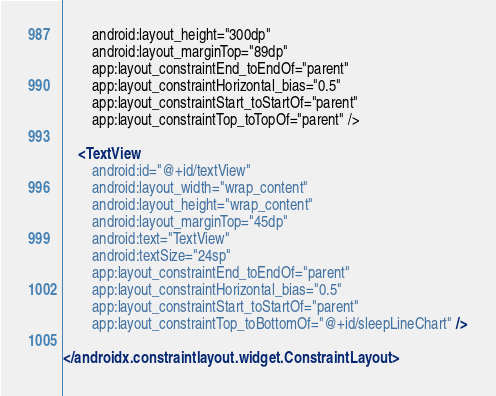Convert code to text. <code><loc_0><loc_0><loc_500><loc_500><_XML_>        android:layout_height="300dp"
        android:layout_marginTop="89dp"
        app:layout_constraintEnd_toEndOf="parent"
        app:layout_constraintHorizontal_bias="0.5"
        app:layout_constraintStart_toStartOf="parent"
        app:layout_constraintTop_toTopOf="parent" />

    <TextView
        android:id="@+id/textView"
        android:layout_width="wrap_content"
        android:layout_height="wrap_content"
        android:layout_marginTop="45dp"
        android:text="TextView"
        android:textSize="24sp"
        app:layout_constraintEnd_toEndOf="parent"
        app:layout_constraintHorizontal_bias="0.5"
        app:layout_constraintStart_toStartOf="parent"
        app:layout_constraintTop_toBottomOf="@+id/sleepLineChart" />

</androidx.constraintlayout.widget.ConstraintLayout></code> 